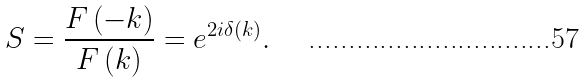<formula> <loc_0><loc_0><loc_500><loc_500>S = \frac { F \left ( - k \right ) } { F \left ( k \right ) } = e ^ { 2 i \delta \left ( k \right ) } .</formula> 